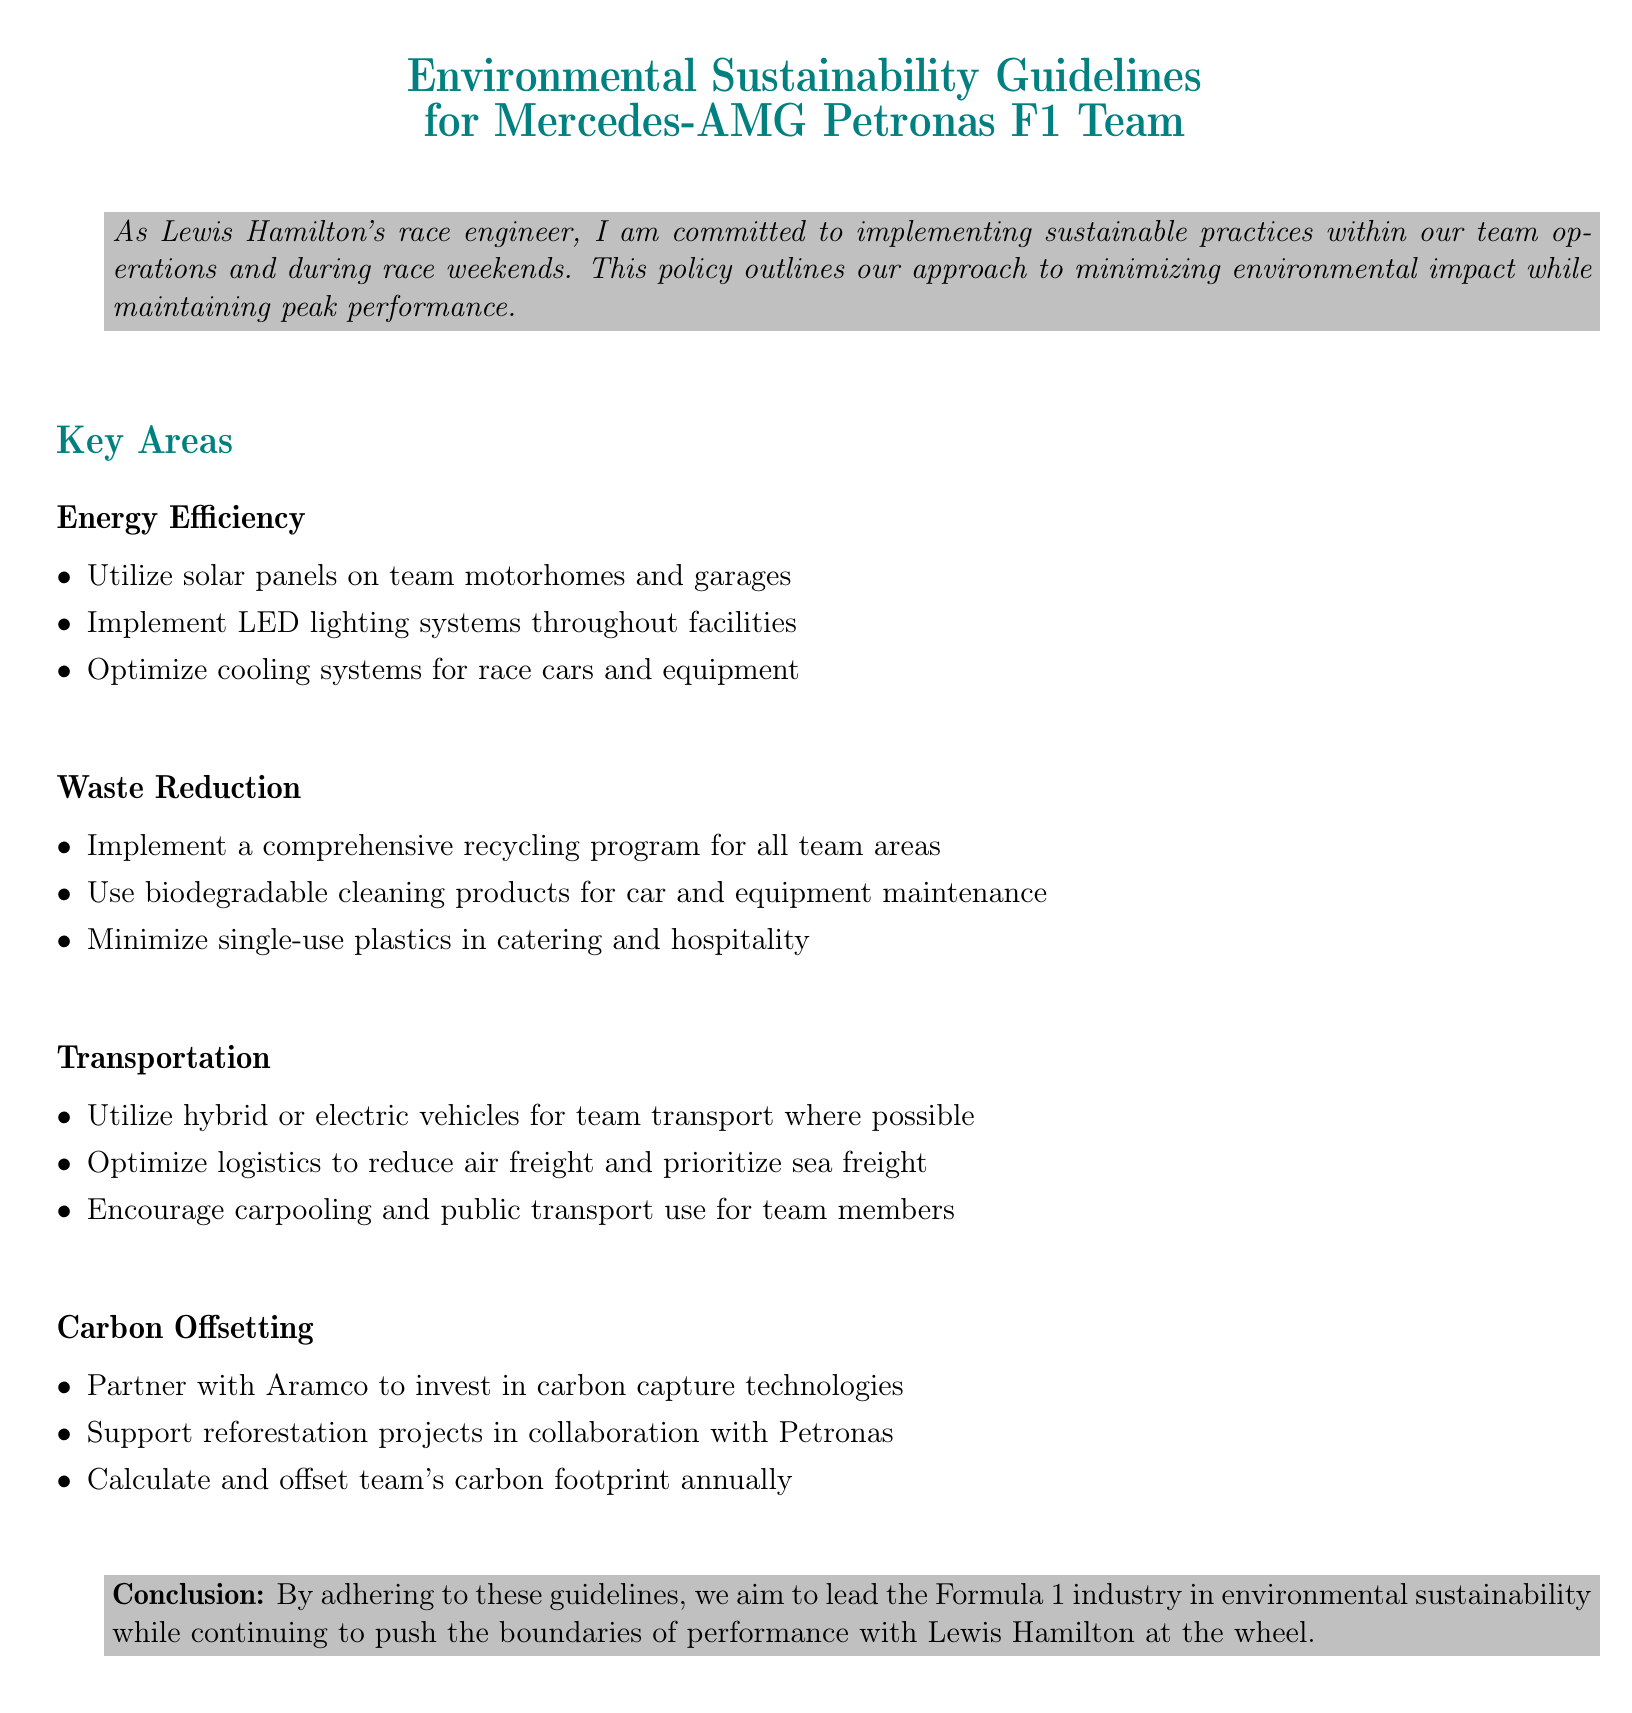What is the title of the document? The title of the document is "Environmental Sustainability Guidelines for Mercedes-AMG Petronas F1 Team".
Answer: Environmental Sustainability Guidelines for Mercedes-AMG Petronas F1 Team What sustainable energy source is used on team motorhomes? The document states that solar panels are utilized on team motorhomes.
Answer: Solar panels What type of lighting is implemented throughout the facilities? The guidelines mention that LED lighting systems are implemented throughout the facilities.
Answer: LED lighting systems What type of vehicles are encouraged for team transport? The document states to utilize hybrid or electric vehicles for team transport where possible.
Answer: Hybrid or electric vehicles Who is partnered with the team for carbon capture technologies? The guidelines mention partnering with Aramco for investing in carbon capture technologies.
Answer: Aramco Which cleaning products are recommended for maintenance? The document recommends using biodegradable cleaning products for car and equipment maintenance.
Answer: Biodegradable cleaning products How does the team plan to support reforestation? The document mentions supporting reforestation projects in collaboration with Petronas.
Answer: Petronas What is the purpose of the recycling program? The comprehensive recycling program aims to reduce waste in all team areas.
Answer: Reduce waste What does the team aim to lead in the Formula 1 industry? The conclusion states that the team aims to lead in environmental sustainability.
Answer: Environmental sustainability 